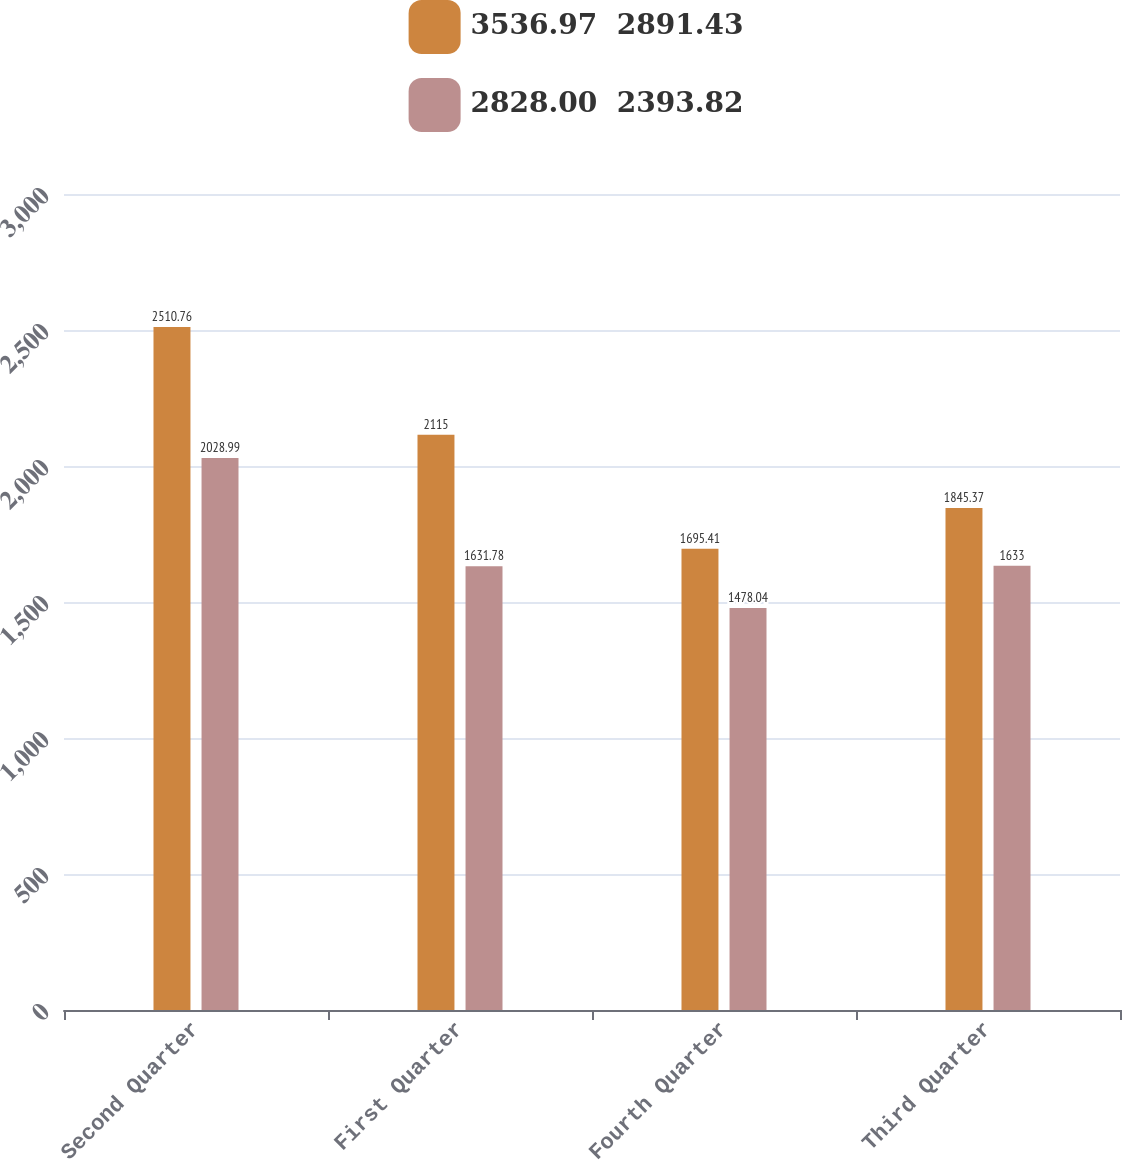Convert chart. <chart><loc_0><loc_0><loc_500><loc_500><stacked_bar_chart><ecel><fcel>Second Quarter<fcel>First Quarter<fcel>Fourth Quarter<fcel>Third Quarter<nl><fcel>3536.97  2891.43<fcel>2510.76<fcel>2115<fcel>1695.41<fcel>1845.37<nl><fcel>2828.00  2393.82<fcel>2028.99<fcel>1631.78<fcel>1478.04<fcel>1633<nl></chart> 